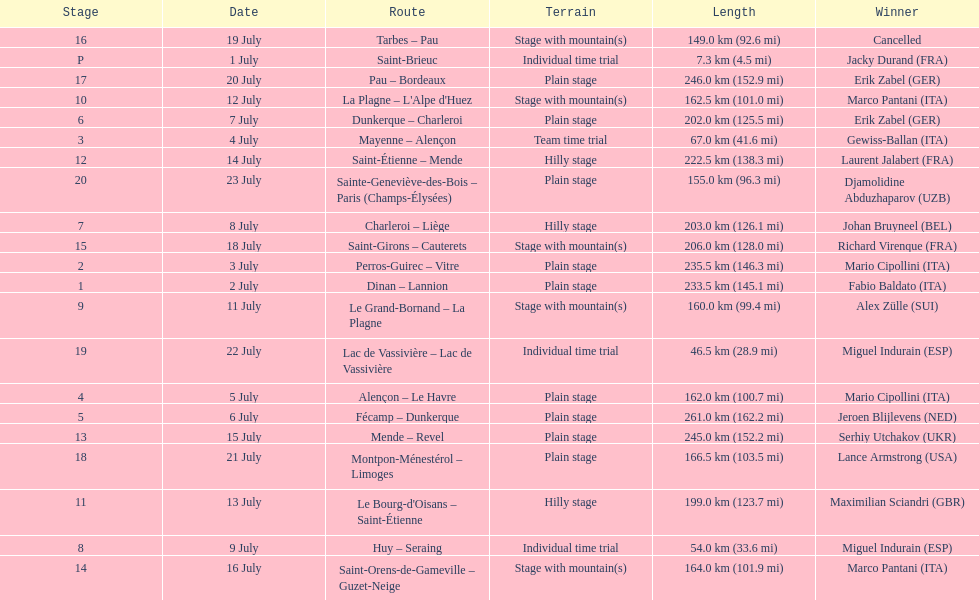After lance armstrong, who led next in the 1995 tour de france? Miguel Indurain. 